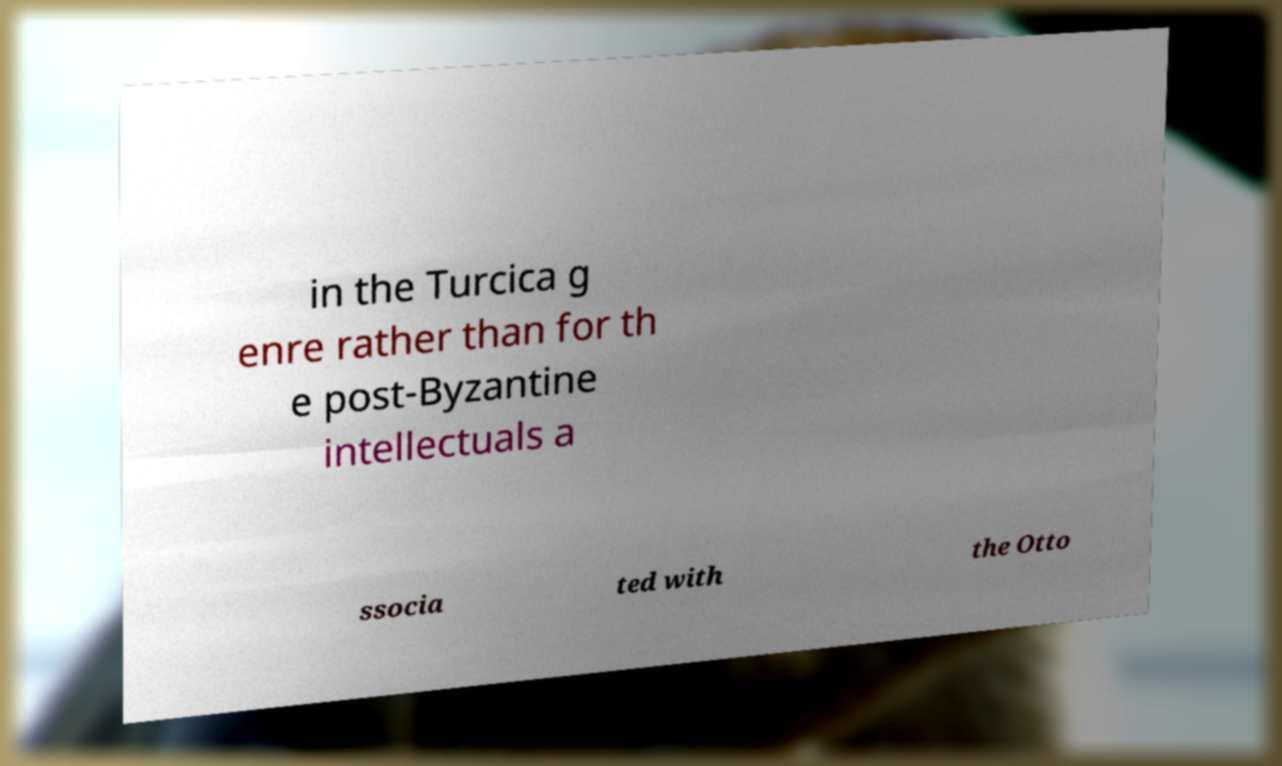What messages or text are displayed in this image? I need them in a readable, typed format. in the Turcica g enre rather than for th e post-Byzantine intellectuals a ssocia ted with the Otto 